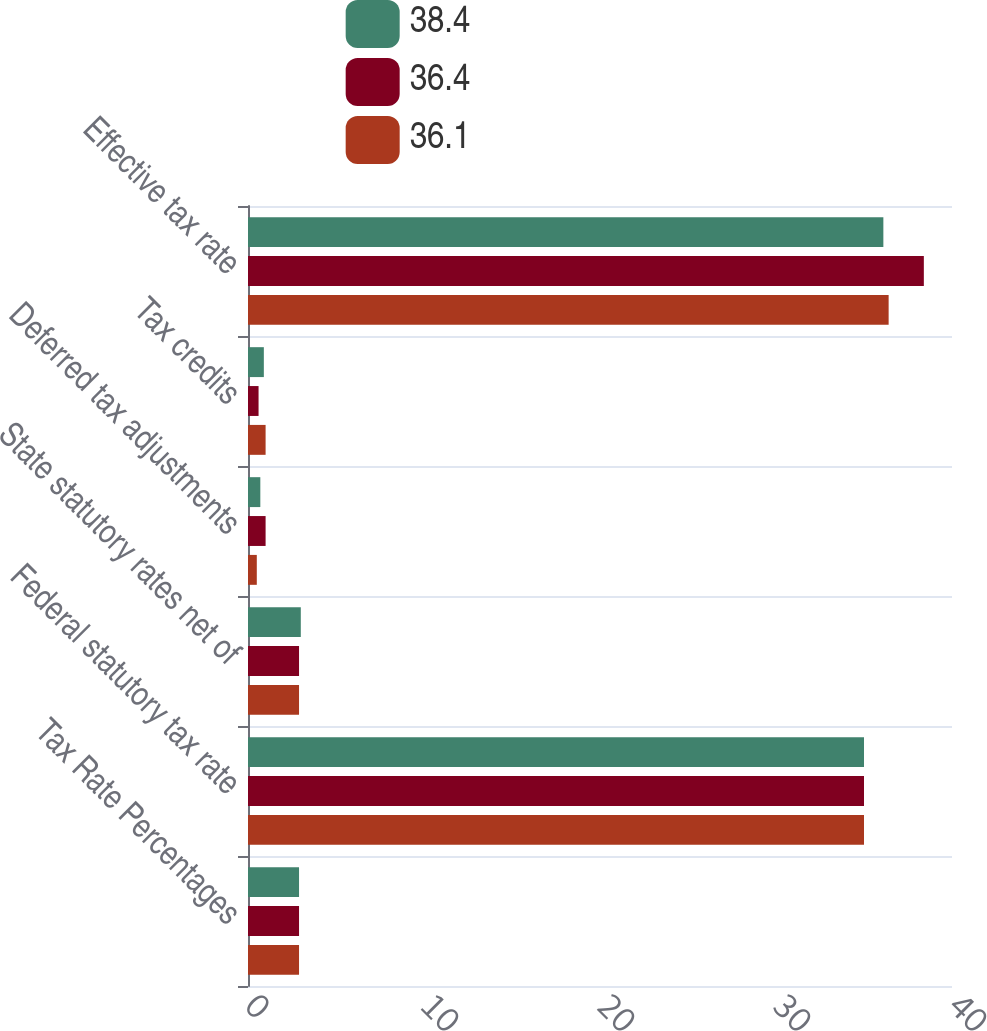Convert chart to OTSL. <chart><loc_0><loc_0><loc_500><loc_500><stacked_bar_chart><ecel><fcel>Tax Rate Percentages<fcel>Federal statutory tax rate<fcel>State statutory rates net of<fcel>Deferred tax adjustments<fcel>Tax credits<fcel>Effective tax rate<nl><fcel>38.4<fcel>2.9<fcel>35<fcel>3<fcel>0.7<fcel>0.9<fcel>36.1<nl><fcel>36.4<fcel>2.9<fcel>35<fcel>2.9<fcel>1<fcel>0.6<fcel>38.4<nl><fcel>36.1<fcel>2.9<fcel>35<fcel>2.9<fcel>0.5<fcel>1<fcel>36.4<nl></chart> 